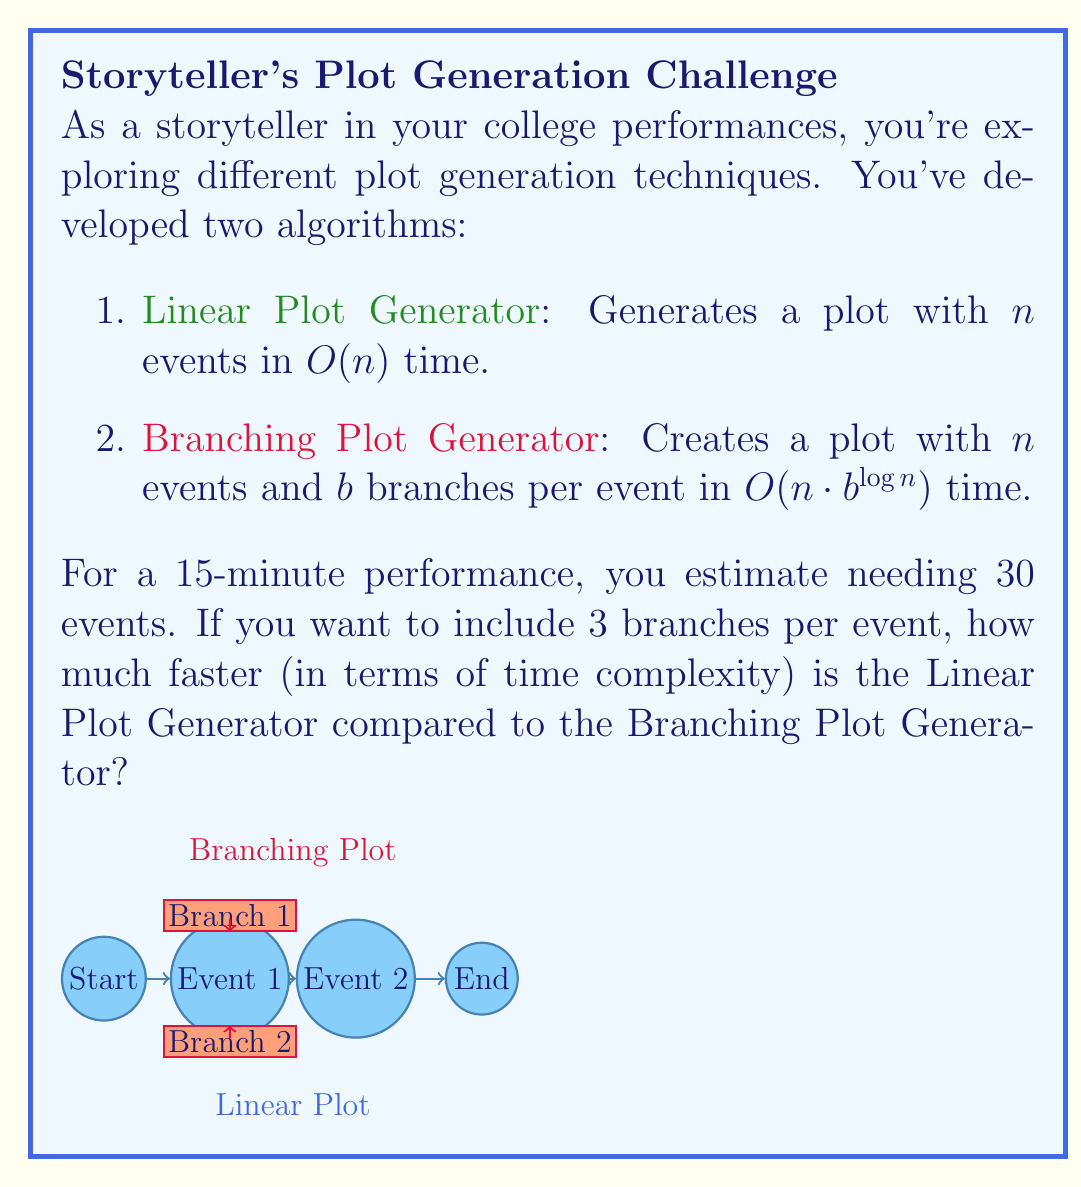Could you help me with this problem? Let's approach this step-by-step:

1) For the Linear Plot Generator:
   - Time complexity: $O(n)$
   - With $n = 30$ events, the time complexity is $O(30) = O(n)$

2) For the Branching Plot Generator:
   - Time complexity: $O(n \cdot b^{\log n})$
   - We have $n = 30$ events and $b = 3$ branches per event
   - Substituting these values: $O(30 \cdot 3^{\log 30})$

3) To simplify $3^{\log 30}$:
   - $\log 30 \approx 4.91$ (using base 2 logarithm)
   - $3^{\log 30} \approx 3^{4.91} \approx 416.88$

4) So, the Branching Plot Generator's time complexity is approximately:
   $O(30 \cdot 416.88) \approx O(12,506) \approx O(n \cdot 3^{\log n})$

5) To compare the two:
   - Linear Plot Generator: $O(n)$
   - Branching Plot Generator: $O(n \cdot 3^{\log n})$

6) The ratio of their complexities:
   $$\frac{O(n \cdot 3^{\log n})}{O(n)} = O(3^{\log n})$$

7) With $n = 30$, this ratio is approximately $O(416.88)$

Therefore, the Linear Plot Generator is approximately $O(3^{\log n}) \approx O(417)$ times faster than the Branching Plot Generator for this scenario.
Answer: $O(3^{\log n})$ times faster 